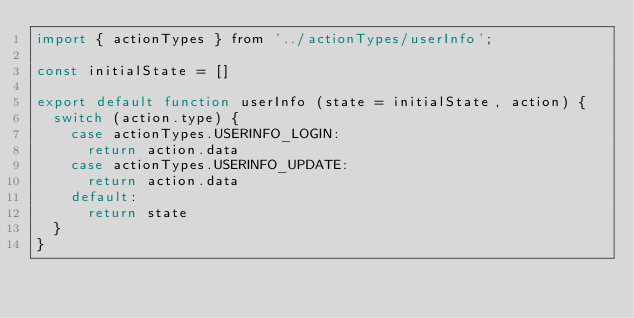Convert code to text. <code><loc_0><loc_0><loc_500><loc_500><_JavaScript_>import { actionTypes } from '../actionTypes/userInfo';

const initialState = []

export default function userInfo (state = initialState, action) {
  switch (action.type) {
    case actionTypes.USERINFO_LOGIN:
      return action.data
    case actionTypes.USERINFO_UPDATE:
      return action.data
    default:
      return state
  }
}
</code> 